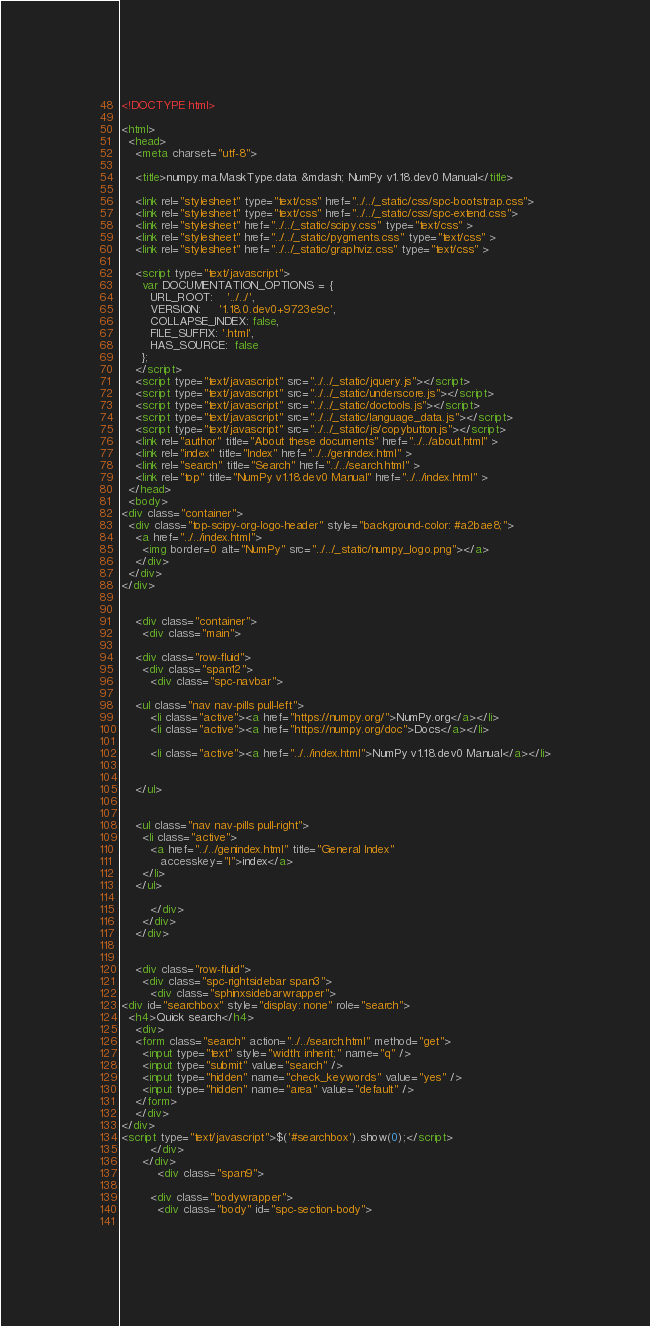Convert code to text. <code><loc_0><loc_0><loc_500><loc_500><_HTML_><!DOCTYPE html>

<html>
  <head>
    <meta charset="utf-8">
    
    <title>numpy.ma.MaskType.data &mdash; NumPy v1.18.dev0 Manual</title>
    
    <link rel="stylesheet" type="text/css" href="../../_static/css/spc-bootstrap.css">
    <link rel="stylesheet" type="text/css" href="../../_static/css/spc-extend.css">
    <link rel="stylesheet" href="../../_static/scipy.css" type="text/css" >
    <link rel="stylesheet" href="../../_static/pygments.css" type="text/css" >
    <link rel="stylesheet" href="../../_static/graphviz.css" type="text/css" >
    
    <script type="text/javascript">
      var DOCUMENTATION_OPTIONS = {
        URL_ROOT:    '../../',
        VERSION:     '1.18.0.dev0+9723e9c',
        COLLAPSE_INDEX: false,
        FILE_SUFFIX: '.html',
        HAS_SOURCE:  false
      };
    </script>
    <script type="text/javascript" src="../../_static/jquery.js"></script>
    <script type="text/javascript" src="../../_static/underscore.js"></script>
    <script type="text/javascript" src="../../_static/doctools.js"></script>
    <script type="text/javascript" src="../../_static/language_data.js"></script>
    <script type="text/javascript" src="../../_static/js/copybutton.js"></script>
    <link rel="author" title="About these documents" href="../../about.html" >
    <link rel="index" title="Index" href="../../genindex.html" >
    <link rel="search" title="Search" href="../../search.html" >
    <link rel="top" title="NumPy v1.18.dev0 Manual" href="../../index.html" > 
  </head>
  <body>
<div class="container">
  <div class="top-scipy-org-logo-header" style="background-color: #a2bae8;">
    <a href="../../index.html">
      <img border=0 alt="NumPy" src="../../_static/numpy_logo.png"></a>
    </div>
  </div>
</div>


    <div class="container">
      <div class="main">
        
	<div class="row-fluid">
	  <div class="span12">
	    <div class="spc-navbar">
              
    <ul class="nav nav-pills pull-left">
        <li class="active"><a href="https://numpy.org/">NumPy.org</a></li>
        <li class="active"><a href="https://numpy.org/doc">Docs</a></li>
        
        <li class="active"><a href="../../index.html">NumPy v1.18.dev0 Manual</a></li>
        
 
    </ul>
              
              
    <ul class="nav nav-pills pull-right">
      <li class="active">
        <a href="../../genindex.html" title="General Index"
           accesskey="I">index</a>
      </li>
    </ul>
              
	    </div>
	  </div>
	</div>
        

	<div class="row-fluid">
      <div class="spc-rightsidebar span3">
        <div class="sphinxsidebarwrapper">
<div id="searchbox" style="display: none" role="search">
  <h4>Quick search</h4>
    <div>
    <form class="search" action="../../search.html" method="get">
      <input type="text" style="width: inherit;" name="q" />
      <input type="submit" value="search" />
      <input type="hidden" name="check_keywords" value="yes" />
      <input type="hidden" name="area" value="default" />
    </form>
    </div>
</div>
<script type="text/javascript">$('#searchbox').show(0);</script>
        </div>
      </div>
          <div class="span9">
            
        <div class="bodywrapper">
          <div class="body" id="spc-section-body">
            </code> 